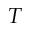<formula> <loc_0><loc_0><loc_500><loc_500>T</formula> 